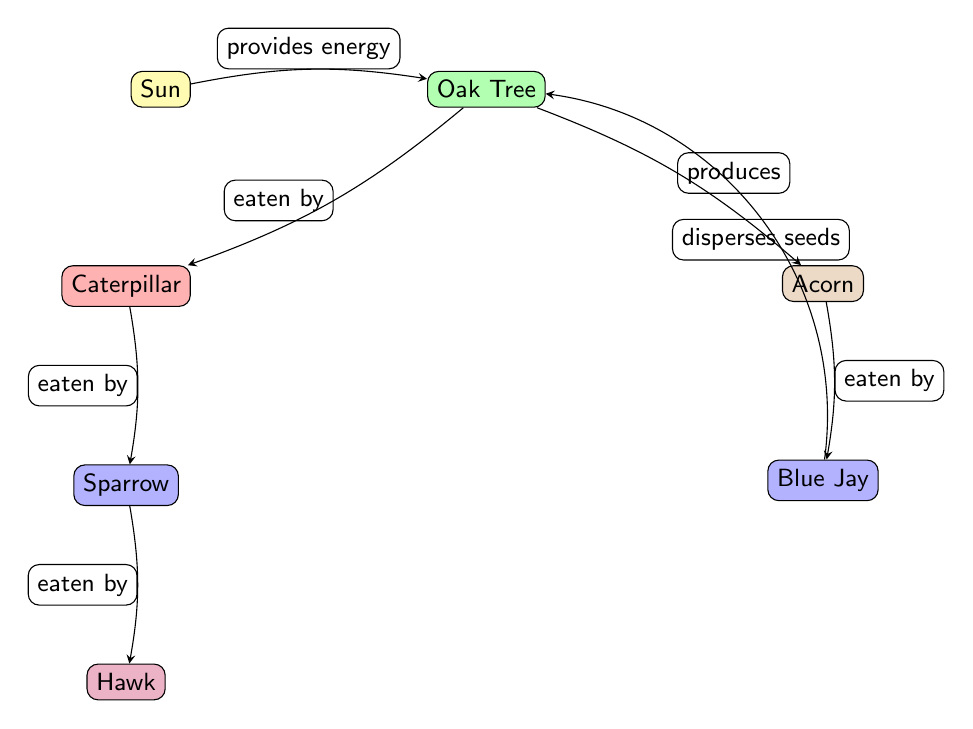What is the producer in this food chain? A producer in a food chain is typically a plant or another organism that produces energy for the food web. In this diagram, the oak tree is listed as the producer, as it receives energy from the sun and produces acorns.
Answer: Oak Tree How many birds are present in the diagram? The diagram shows two birds: the blue jay and the sparrow. Therefore, by counting these visual representations, we find that there are two species of birds in the food chain.
Answer: 2 What role does the blue jay serve in the ecosystem depicted? The blue jay is depicted as a bird that disperses seeds. This information is derived directly from its labeled relationship in the diagram, indicating its ecological function in helping the oak tree produce new growth.
Answer: Disperses seeds Which node is eaten by the hawk? The hawk is shown eating the sparrow according to the arrows and labels in the diagram, indicating a predator-prey relationship in the food chain. By following the directional flow of the diagram, we identify the sparrow as its prey.
Answer: Sparrow What do caterpillars eat? The caterpillar is depicted in the diagram as eating the oak tree. The relationship demonstrated by the arrow indicates that the caterpillar derives its nutrition from the oak tree, which provides it with sustenance.
Answer: Oak Tree How do blue jays contribute to the oak tree's life cycle? The blue jays contribute to the oak tree's life cycle by dispersing seeds, as indicated in the diagram. This shows that the blue jays help in the propagation of new oak trees by spreading acorns, which is crucial for the tree's reproduction.
Answer: Disperses seeds Which insect is shown in this ecosystem? The diagram illustrates a caterpillar, clearly labeled and represented in the food chain. This insect is part of the interaction between the oak tree and other species, showing its role in consuming plant life.
Answer: Caterpillar What is the relationship between the sparrow and the hawk? The hawk preys on the sparrow, which is indicated by the arrow pointing from the sparrow to the hawk in the diagram. This relationship highlights a predator-prey dynamic within this food chain.
Answer: Eaten by How does the energy flow begin in the food chain? Energy flow in the food chain begins with the sun, which provides energy that is utilized by the oak tree, establishing the primary energy source for the ecosystem depicted in the diagram.
Answer: Sun 